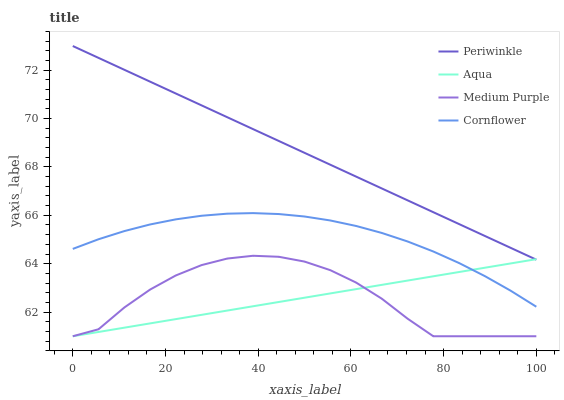Does Aqua have the minimum area under the curve?
Answer yes or no. Yes. Does Periwinkle have the maximum area under the curve?
Answer yes or no. Yes. Does Periwinkle have the minimum area under the curve?
Answer yes or no. No. Does Aqua have the maximum area under the curve?
Answer yes or no. No. Is Aqua the smoothest?
Answer yes or no. Yes. Is Medium Purple the roughest?
Answer yes or no. Yes. Is Periwinkle the smoothest?
Answer yes or no. No. Is Periwinkle the roughest?
Answer yes or no. No. Does Medium Purple have the lowest value?
Answer yes or no. Yes. Does Periwinkle have the lowest value?
Answer yes or no. No. Does Periwinkle have the highest value?
Answer yes or no. Yes. Does Aqua have the highest value?
Answer yes or no. No. Is Medium Purple less than Cornflower?
Answer yes or no. Yes. Is Cornflower greater than Medium Purple?
Answer yes or no. Yes. Does Aqua intersect Medium Purple?
Answer yes or no. Yes. Is Aqua less than Medium Purple?
Answer yes or no. No. Is Aqua greater than Medium Purple?
Answer yes or no. No. Does Medium Purple intersect Cornflower?
Answer yes or no. No. 